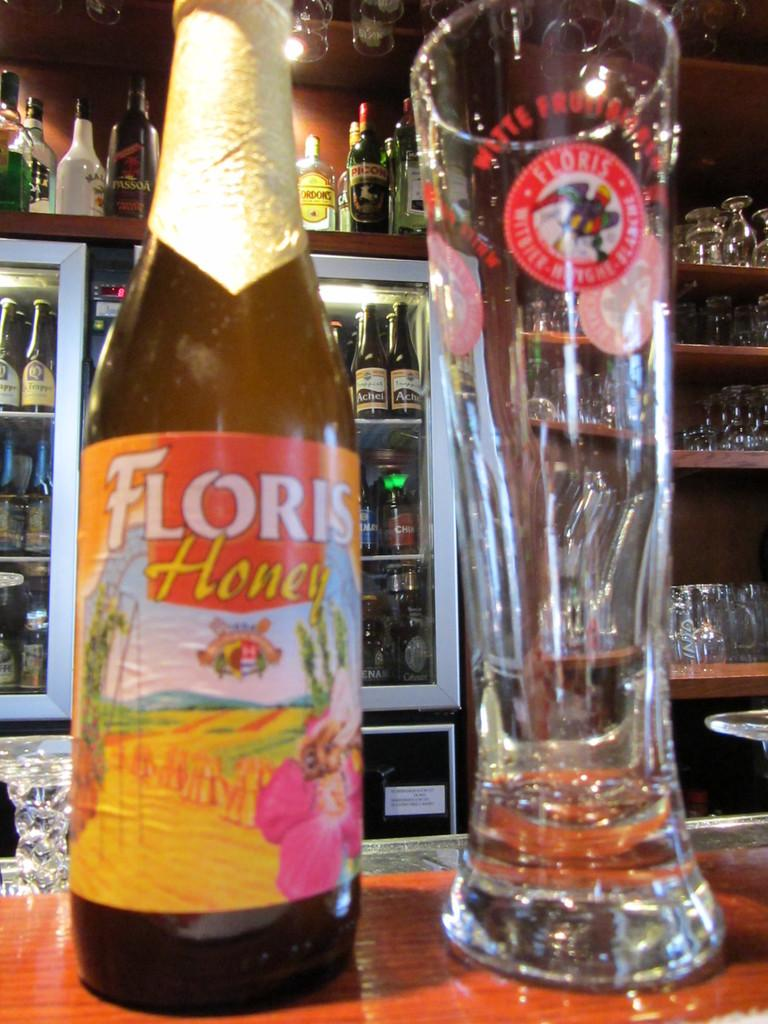<image>
Summarize the visual content of the image. A bottle labeled Floris Honey is next to a large glass. 